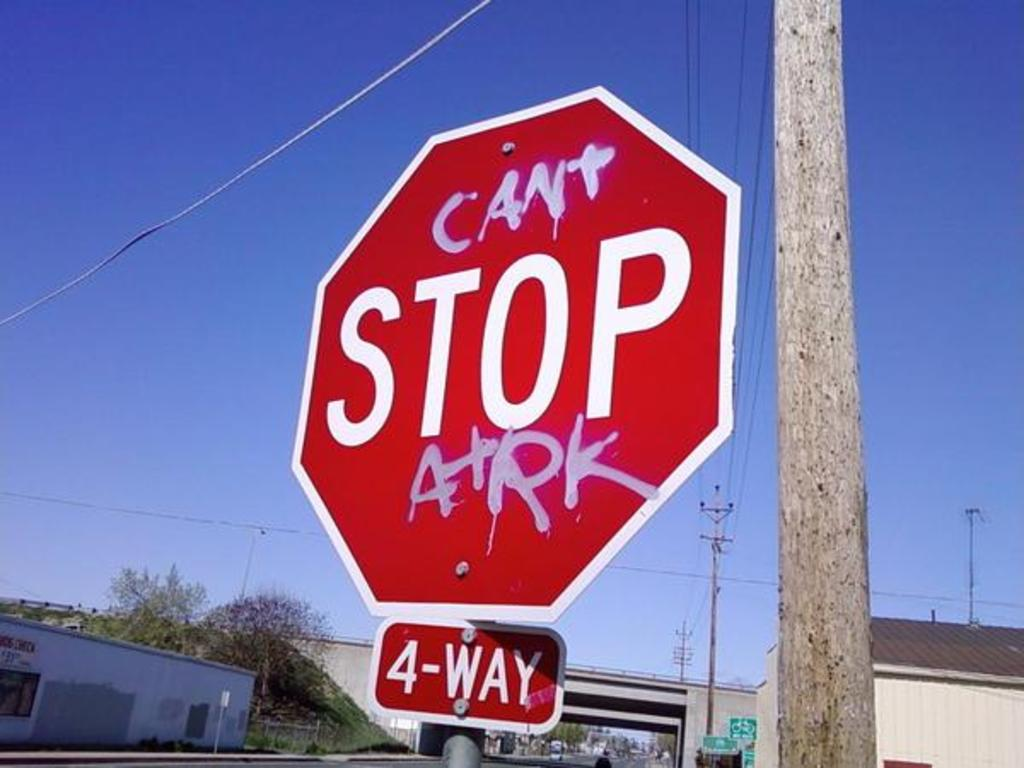What does the addition of 'ARK' suggest about the community or the individual who edited the sign? The inclusion of 'ARK' on the stop sign suggests that this act of vandalism may be connected to a specific group, cause, or individual known as 'ARK'. This could be a tag used by a local artist or a group making a statement, implying a layer of communal identity or social commentary. The nature of the message, playful yet defiant, hints at a spirit of nonconformity prevalent within the community or among certain individuals who feel a degree of impunity or desire to communicate with the broader public in an unconventional way. 